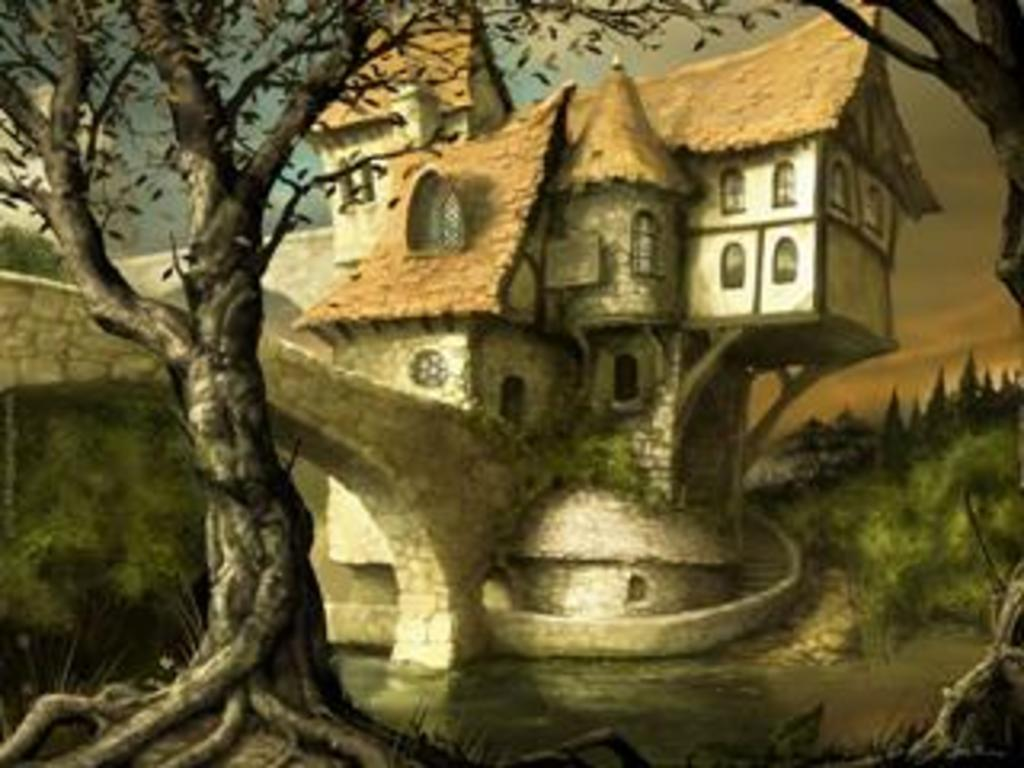What is the main subject of the painting in the image? The painting depicts a tree, a bridge, and a house. What is the background of the painting? The background of the painting is the sky. Can you see any quicksand in the painting? No, there is no quicksand present in the painting. Are there any fairies depicted in the painting? No, there are no fairies depicted in the painting. 